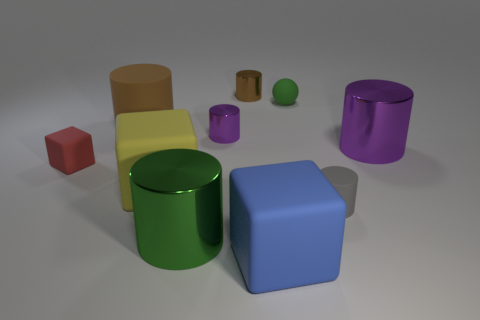Subtract all purple cylinders. How many were subtracted if there are1purple cylinders left? 1 Subtract 4 cylinders. How many cylinders are left? 2 Subtract all green cylinders. How many cylinders are left? 5 Subtract all purple shiny cylinders. How many cylinders are left? 4 Subtract all green cylinders. Subtract all green blocks. How many cylinders are left? 5 Subtract all blocks. How many objects are left? 7 Subtract 0 yellow balls. How many objects are left? 10 Subtract all brown matte cylinders. Subtract all green shiny cylinders. How many objects are left? 8 Add 6 big brown things. How many big brown things are left? 7 Add 4 tiny cyan cubes. How many tiny cyan cubes exist? 4 